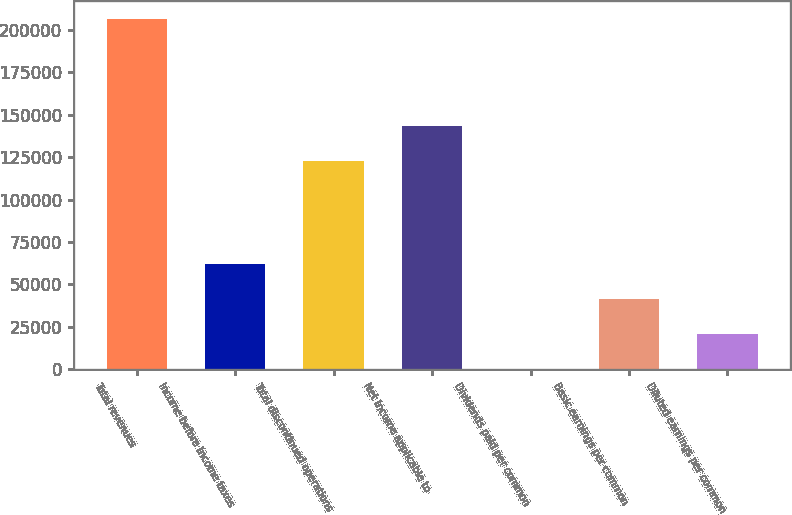Convert chart to OTSL. <chart><loc_0><loc_0><loc_500><loc_500><bar_chart><fcel>Total revenues<fcel>Income before income taxes<fcel>Total discontinued operations<fcel>Net income applicable to<fcel>Dividends paid per common<fcel>Basic earnings per common<fcel>Diluted earnings per common<nl><fcel>206503<fcel>61951.2<fcel>122737<fcel>143387<fcel>0.45<fcel>41301<fcel>20650.7<nl></chart> 